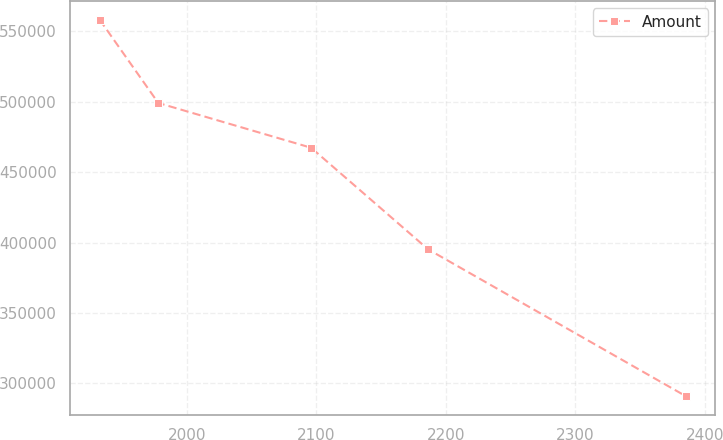Convert chart. <chart><loc_0><loc_0><loc_500><loc_500><line_chart><ecel><fcel>Amount<nl><fcel>1932.61<fcel>558369<nl><fcel>1977.89<fcel>499189<nl><fcel>2095.89<fcel>467397<nl><fcel>2186.2<fcel>395252<nl><fcel>2385.43<fcel>290841<nl></chart> 